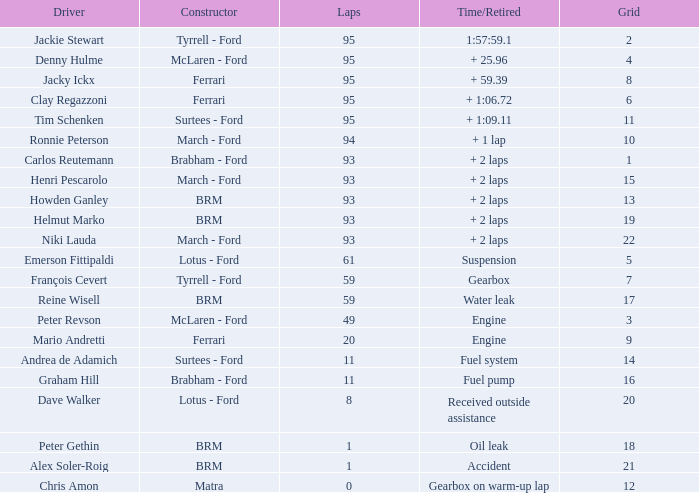What is the smallest grid with matra as creator? 12.0. 